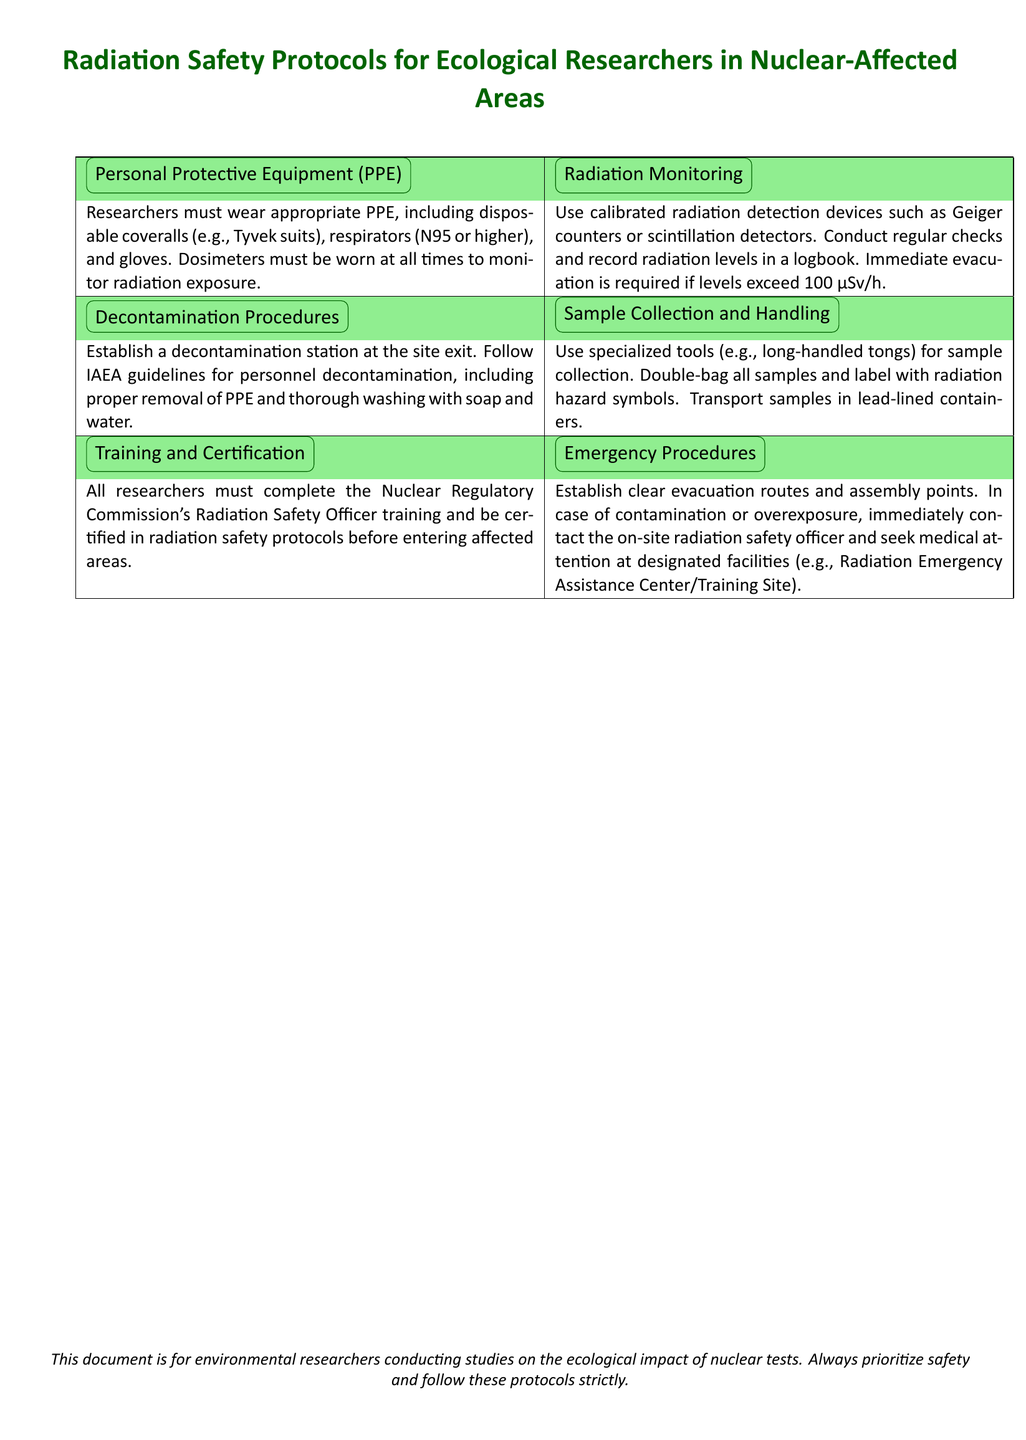What personal protective equipment must researchers wear? The document specifies that researchers must wear disposable coveralls, respirators, and gloves as personal protective equipment.
Answer: disposable coveralls, respirators, gloves What is the maximum allowable radiation level before evacuation is required? The document states that immediate evacuation is required if radiation levels exceed 100 μSv/h.
Answer: 100 μSv/h What training must researchers complete? According to the document, all researchers must complete the Nuclear Regulatory Commission's Radiation Safety Officer training.
Answer: Nuclear Regulatory Commission's Radiation Safety Officer training What should be used for sample collection? The document mentions that specialized tools, such as long-handled tongs, should be used for sample collection.
Answer: long-handled tongs What is the first step in decontamination procedures? The document indicates that establishing a decontamination station at the site exit is the first step in decontamination procedures.
Answer: decontamination station at the site exit How often should radiation levels be recorded? The document suggests that radiation levels should be recorded regularly in a logbook.
Answer: regularly What type of containers should be used to transport samples? The document states that samples should be transported in lead-lined containers.
Answer: lead-lined containers What must be established in case of contamination or overexposure? The document specifies that clear evacuation routes and assembly points must be established in case of contamination or overexposure.
Answer: evacuation routes and assembly points What organization must the radiation safety officer belong to? The document states that in case of contamination or overexposure, the on-site officer must help, implying their connection to the relevant radiation safety authority.
Answer: Radiation Safety Officer 